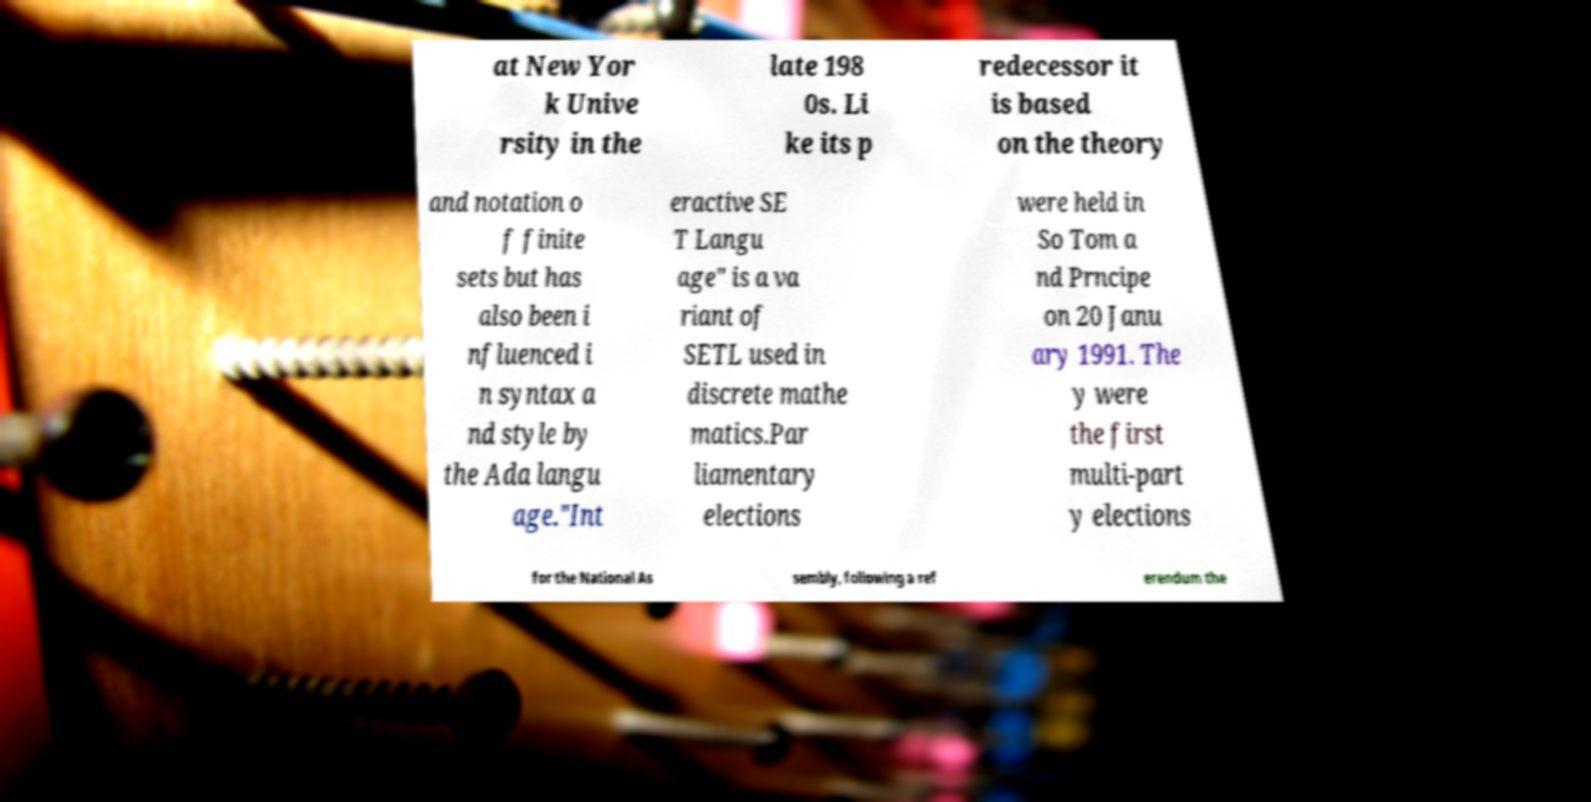I need the written content from this picture converted into text. Can you do that? at New Yor k Unive rsity in the late 198 0s. Li ke its p redecessor it is based on the theory and notation o f finite sets but has also been i nfluenced i n syntax a nd style by the Ada langu age."Int eractive SE T Langu age" is a va riant of SETL used in discrete mathe matics.Par liamentary elections were held in So Tom a nd Prncipe on 20 Janu ary 1991. The y were the first multi-part y elections for the National As sembly, following a ref erendum the 